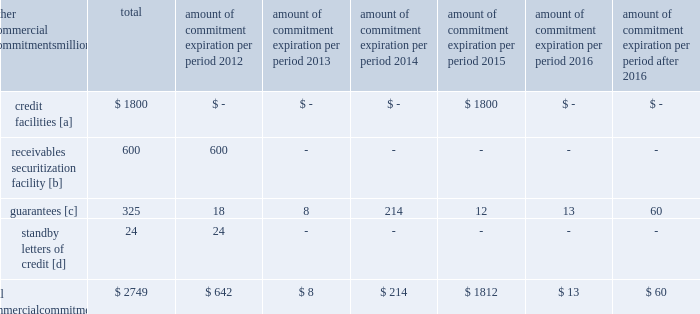Amount of commitment expiration per period other commercial commitments after millions total 2012 2013 2014 2015 2016 2016 .
[a] none of the credit facility was used as of december 31 , 2011 .
[b] $ 100 million of the receivables securitization facility was utilized at december 31 , 2011 , which is accounted for as debt .
The full program matures in august 2012 .
[c] includes guaranteed obligations related to our headquarters building , equipment financings , and affiliated operations .
[d] none of the letters of credit were drawn upon as of december 31 , 2011 .
Off-balance sheet arrangements guarantees 2013 at december 31 , 2011 , we were contingently liable for $ 325 million in guarantees .
We have recorded a liability of $ 3 million for the fair value of these obligations as of december 31 , 2011 and 2010 .
We entered into these contingent guarantees in the normal course of business , and they include guaranteed obligations related to our headquarters building , equipment financings , and affiliated operations .
The final guarantee expires in 2022 .
We are not aware of any existing event of default that would require us to satisfy these guarantees .
We do not expect that these guarantees will have a material adverse effect on our consolidated financial condition , results of operations , or liquidity .
Other matters labor agreements 2013 in january 2010 , the nation 2019s largest freight railroads began the current round of negotiations with the labor unions .
Generally , contract negotiations with the various unions take place over an extended period of time .
This round of negotiations was no exception .
In september 2011 , the rail industry reached agreements with the united transportation union .
On november 5 , 2011 , a presidential emergency board ( peb ) appointed by president obama issued recommendations to resolve the disputes between the u.s .
Railroads and 11 unions that had not yet reached agreements .
Since then , ten unions reached agreements with the railroads , all of them generally patterned on the recommendations of the peb , and the unions subsequently ratified these agreements .
The railroad industry reached a tentative agreement with the brotherhood of maintenance of way employees ( bmwe ) on february 2 , 2012 , eliminating the immediate threat of a national rail strike .
The bmwe now will commence ratification of this tentative agreement by its members .
Inflation 2013 long periods of inflation significantly increase asset replacement costs for capital-intensive companies .
As a result , assuming that we replace all operating assets at current price levels , depreciation charges ( on an inflation-adjusted basis ) would be substantially greater than historically reported amounts .
Derivative financial instruments 2013 we may use derivative financial instruments in limited instances to assist in managing our overall exposure to fluctuations in interest rates and fuel prices .
We are not a party to leveraged derivatives and , by policy , do not use derivative financial instruments for speculative purposes .
Derivative financial instruments qualifying for hedge accounting must maintain a specified level of effectiveness between the hedging instrument and the item being hedged , both at inception and throughout the hedged period .
We formally document the nature and relationships between the hedging instruments and hedged items at inception , as well as our risk-management objectives , strategies for undertaking the various hedge transactions , and method of assessing hedge effectiveness .
Changes in the fair market value of derivative financial instruments that do not qualify for hedge accounting are charged to earnings .
We may use swaps , collars , futures , and/or forward contracts to mitigate the risk of adverse movements in interest rates and fuel prices ; however , the use of these derivative financial instruments may limit future benefits from favorable price movements. .
What percent of total commercial commitments are credit facilities? 
Computations: (1800 / 2749)
Answer: 0.65478. 